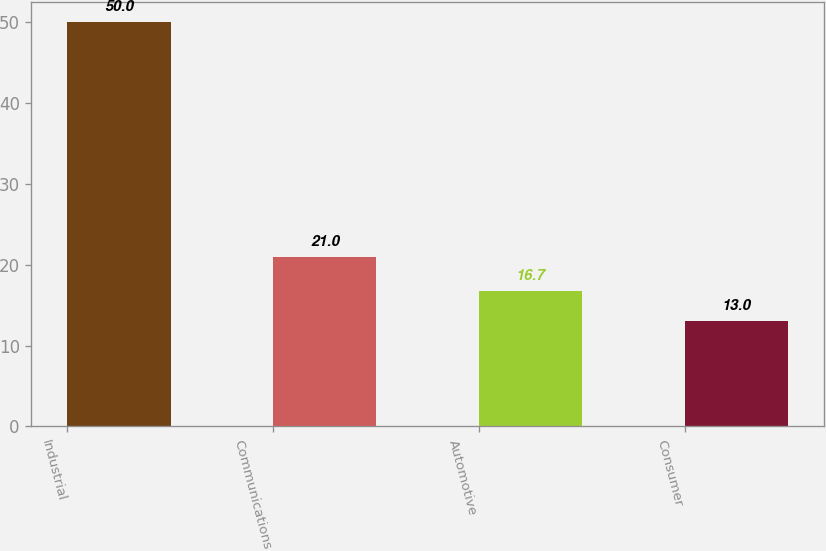Convert chart. <chart><loc_0><loc_0><loc_500><loc_500><bar_chart><fcel>Industrial<fcel>Communications<fcel>Automotive<fcel>Consumer<nl><fcel>50<fcel>21<fcel>16.7<fcel>13<nl></chart> 